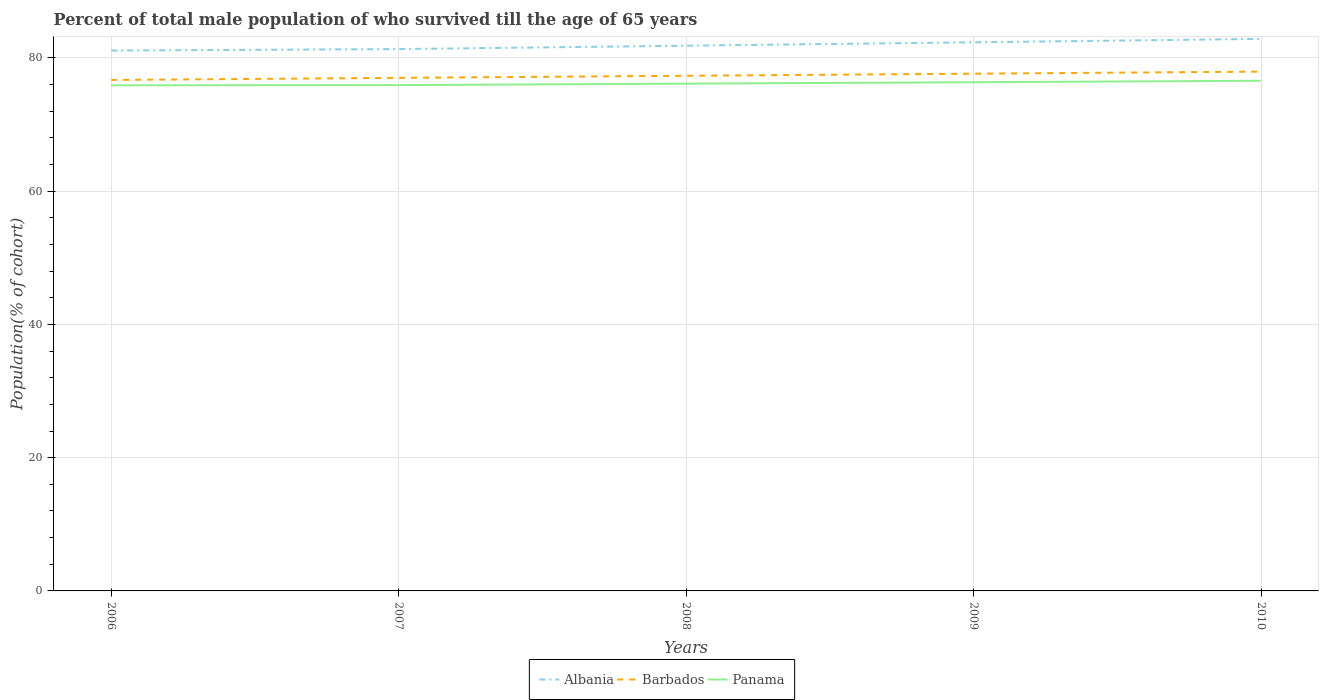Is the number of lines equal to the number of legend labels?
Your answer should be very brief. Yes. Across all years, what is the maximum percentage of total male population who survived till the age of 65 years in Barbados?
Offer a very short reply. 76.7. In which year was the percentage of total male population who survived till the age of 65 years in Panama maximum?
Give a very brief answer. 2006. What is the total percentage of total male population who survived till the age of 65 years in Panama in the graph?
Offer a very short reply. -0.25. What is the difference between the highest and the second highest percentage of total male population who survived till the age of 65 years in Panama?
Your answer should be very brief. 0.68. Is the percentage of total male population who survived till the age of 65 years in Albania strictly greater than the percentage of total male population who survived till the age of 65 years in Panama over the years?
Keep it short and to the point. No. How many lines are there?
Offer a terse response. 3. How many years are there in the graph?
Offer a terse response. 5. Does the graph contain grids?
Provide a succinct answer. Yes. How many legend labels are there?
Your response must be concise. 3. What is the title of the graph?
Provide a succinct answer. Percent of total male population of who survived till the age of 65 years. What is the label or title of the Y-axis?
Offer a very short reply. Population(% of cohort). What is the Population(% of cohort) in Albania in 2006?
Make the answer very short. 81.12. What is the Population(% of cohort) in Barbados in 2006?
Your answer should be very brief. 76.7. What is the Population(% of cohort) of Panama in 2006?
Your response must be concise. 75.9. What is the Population(% of cohort) in Albania in 2007?
Your answer should be very brief. 81.34. What is the Population(% of cohort) of Barbados in 2007?
Ensure brevity in your answer.  77.02. What is the Population(% of cohort) of Panama in 2007?
Ensure brevity in your answer.  75.93. What is the Population(% of cohort) of Albania in 2008?
Provide a short and direct response. 81.85. What is the Population(% of cohort) in Barbados in 2008?
Offer a very short reply. 77.33. What is the Population(% of cohort) in Panama in 2008?
Your response must be concise. 76.15. What is the Population(% of cohort) in Albania in 2009?
Make the answer very short. 82.36. What is the Population(% of cohort) in Barbados in 2009?
Your answer should be compact. 77.64. What is the Population(% of cohort) in Panama in 2009?
Provide a short and direct response. 76.37. What is the Population(% of cohort) of Albania in 2010?
Give a very brief answer. 82.87. What is the Population(% of cohort) of Barbados in 2010?
Ensure brevity in your answer.  77.96. What is the Population(% of cohort) in Panama in 2010?
Provide a short and direct response. 76.58. Across all years, what is the maximum Population(% of cohort) of Albania?
Your response must be concise. 82.87. Across all years, what is the maximum Population(% of cohort) in Barbados?
Provide a short and direct response. 77.96. Across all years, what is the maximum Population(% of cohort) of Panama?
Keep it short and to the point. 76.58. Across all years, what is the minimum Population(% of cohort) of Albania?
Provide a succinct answer. 81.12. Across all years, what is the minimum Population(% of cohort) of Barbados?
Provide a succinct answer. 76.7. Across all years, what is the minimum Population(% of cohort) in Panama?
Keep it short and to the point. 75.9. What is the total Population(% of cohort) in Albania in the graph?
Ensure brevity in your answer.  409.53. What is the total Population(% of cohort) in Barbados in the graph?
Your answer should be very brief. 386.65. What is the total Population(% of cohort) of Panama in the graph?
Ensure brevity in your answer.  380.93. What is the difference between the Population(% of cohort) of Albania in 2006 and that in 2007?
Provide a short and direct response. -0.22. What is the difference between the Population(% of cohort) in Barbados in 2006 and that in 2007?
Give a very brief answer. -0.32. What is the difference between the Population(% of cohort) of Panama in 2006 and that in 2007?
Your answer should be very brief. -0.03. What is the difference between the Population(% of cohort) of Albania in 2006 and that in 2008?
Give a very brief answer. -0.73. What is the difference between the Population(% of cohort) in Barbados in 2006 and that in 2008?
Keep it short and to the point. -0.63. What is the difference between the Population(% of cohort) of Panama in 2006 and that in 2008?
Your response must be concise. -0.25. What is the difference between the Population(% of cohort) of Albania in 2006 and that in 2009?
Your response must be concise. -1.24. What is the difference between the Population(% of cohort) in Barbados in 2006 and that in 2009?
Ensure brevity in your answer.  -0.94. What is the difference between the Population(% of cohort) of Panama in 2006 and that in 2009?
Make the answer very short. -0.46. What is the difference between the Population(% of cohort) in Albania in 2006 and that in 2010?
Ensure brevity in your answer.  -1.75. What is the difference between the Population(% of cohort) in Barbados in 2006 and that in 2010?
Offer a very short reply. -1.26. What is the difference between the Population(% of cohort) in Panama in 2006 and that in 2010?
Ensure brevity in your answer.  -0.68. What is the difference between the Population(% of cohort) of Albania in 2007 and that in 2008?
Give a very brief answer. -0.51. What is the difference between the Population(% of cohort) of Barbados in 2007 and that in 2008?
Your response must be concise. -0.31. What is the difference between the Population(% of cohort) of Panama in 2007 and that in 2008?
Ensure brevity in your answer.  -0.22. What is the difference between the Population(% of cohort) of Albania in 2007 and that in 2009?
Your answer should be very brief. -1.02. What is the difference between the Population(% of cohort) of Barbados in 2007 and that in 2009?
Your answer should be compact. -0.62. What is the difference between the Population(% of cohort) in Panama in 2007 and that in 2009?
Your response must be concise. -0.43. What is the difference between the Population(% of cohort) of Albania in 2007 and that in 2010?
Your answer should be very brief. -1.53. What is the difference between the Population(% of cohort) of Barbados in 2007 and that in 2010?
Give a very brief answer. -0.94. What is the difference between the Population(% of cohort) of Panama in 2007 and that in 2010?
Your answer should be compact. -0.65. What is the difference between the Population(% of cohort) of Albania in 2008 and that in 2009?
Offer a very short reply. -0.51. What is the difference between the Population(% of cohort) of Barbados in 2008 and that in 2009?
Give a very brief answer. -0.31. What is the difference between the Population(% of cohort) of Panama in 2008 and that in 2009?
Your response must be concise. -0.22. What is the difference between the Population(% of cohort) of Albania in 2008 and that in 2010?
Keep it short and to the point. -1.02. What is the difference between the Population(% of cohort) in Barbados in 2008 and that in 2010?
Provide a short and direct response. -0.62. What is the difference between the Population(% of cohort) of Panama in 2008 and that in 2010?
Your response must be concise. -0.43. What is the difference between the Population(% of cohort) of Albania in 2009 and that in 2010?
Make the answer very short. -0.51. What is the difference between the Population(% of cohort) of Barbados in 2009 and that in 2010?
Provide a short and direct response. -0.31. What is the difference between the Population(% of cohort) of Panama in 2009 and that in 2010?
Make the answer very short. -0.22. What is the difference between the Population(% of cohort) in Albania in 2006 and the Population(% of cohort) in Barbados in 2007?
Offer a terse response. 4.1. What is the difference between the Population(% of cohort) in Albania in 2006 and the Population(% of cohort) in Panama in 2007?
Your response must be concise. 5.18. What is the difference between the Population(% of cohort) in Barbados in 2006 and the Population(% of cohort) in Panama in 2007?
Offer a very short reply. 0.77. What is the difference between the Population(% of cohort) of Albania in 2006 and the Population(% of cohort) of Barbados in 2008?
Your answer should be very brief. 3.79. What is the difference between the Population(% of cohort) of Albania in 2006 and the Population(% of cohort) of Panama in 2008?
Ensure brevity in your answer.  4.97. What is the difference between the Population(% of cohort) in Barbados in 2006 and the Population(% of cohort) in Panama in 2008?
Your answer should be very brief. 0.55. What is the difference between the Population(% of cohort) of Albania in 2006 and the Population(% of cohort) of Barbados in 2009?
Make the answer very short. 3.47. What is the difference between the Population(% of cohort) of Albania in 2006 and the Population(% of cohort) of Panama in 2009?
Provide a succinct answer. 4.75. What is the difference between the Population(% of cohort) in Barbados in 2006 and the Population(% of cohort) in Panama in 2009?
Keep it short and to the point. 0.34. What is the difference between the Population(% of cohort) in Albania in 2006 and the Population(% of cohort) in Barbados in 2010?
Provide a short and direct response. 3.16. What is the difference between the Population(% of cohort) in Albania in 2006 and the Population(% of cohort) in Panama in 2010?
Offer a very short reply. 4.54. What is the difference between the Population(% of cohort) of Barbados in 2006 and the Population(% of cohort) of Panama in 2010?
Offer a terse response. 0.12. What is the difference between the Population(% of cohort) of Albania in 2007 and the Population(% of cohort) of Barbados in 2008?
Offer a very short reply. 4. What is the difference between the Population(% of cohort) in Albania in 2007 and the Population(% of cohort) in Panama in 2008?
Offer a terse response. 5.19. What is the difference between the Population(% of cohort) in Barbados in 2007 and the Population(% of cohort) in Panama in 2008?
Your response must be concise. 0.87. What is the difference between the Population(% of cohort) in Albania in 2007 and the Population(% of cohort) in Barbados in 2009?
Your answer should be very brief. 3.69. What is the difference between the Population(% of cohort) of Albania in 2007 and the Population(% of cohort) of Panama in 2009?
Keep it short and to the point. 4.97. What is the difference between the Population(% of cohort) of Barbados in 2007 and the Population(% of cohort) of Panama in 2009?
Your answer should be compact. 0.65. What is the difference between the Population(% of cohort) of Albania in 2007 and the Population(% of cohort) of Barbados in 2010?
Provide a short and direct response. 3.38. What is the difference between the Population(% of cohort) in Albania in 2007 and the Population(% of cohort) in Panama in 2010?
Ensure brevity in your answer.  4.76. What is the difference between the Population(% of cohort) of Barbados in 2007 and the Population(% of cohort) of Panama in 2010?
Your answer should be compact. 0.44. What is the difference between the Population(% of cohort) of Albania in 2008 and the Population(% of cohort) of Barbados in 2009?
Ensure brevity in your answer.  4.2. What is the difference between the Population(% of cohort) of Albania in 2008 and the Population(% of cohort) of Panama in 2009?
Offer a terse response. 5.48. What is the difference between the Population(% of cohort) in Barbados in 2008 and the Population(% of cohort) in Panama in 2009?
Give a very brief answer. 0.97. What is the difference between the Population(% of cohort) of Albania in 2008 and the Population(% of cohort) of Barbados in 2010?
Your answer should be very brief. 3.89. What is the difference between the Population(% of cohort) in Albania in 2008 and the Population(% of cohort) in Panama in 2010?
Your response must be concise. 5.27. What is the difference between the Population(% of cohort) of Barbados in 2008 and the Population(% of cohort) of Panama in 2010?
Offer a very short reply. 0.75. What is the difference between the Population(% of cohort) of Albania in 2009 and the Population(% of cohort) of Barbados in 2010?
Make the answer very short. 4.4. What is the difference between the Population(% of cohort) in Albania in 2009 and the Population(% of cohort) in Panama in 2010?
Ensure brevity in your answer.  5.78. What is the difference between the Population(% of cohort) of Barbados in 2009 and the Population(% of cohort) of Panama in 2010?
Give a very brief answer. 1.06. What is the average Population(% of cohort) in Albania per year?
Provide a short and direct response. 81.91. What is the average Population(% of cohort) of Barbados per year?
Offer a terse response. 77.33. What is the average Population(% of cohort) of Panama per year?
Make the answer very short. 76.19. In the year 2006, what is the difference between the Population(% of cohort) in Albania and Population(% of cohort) in Barbados?
Your answer should be compact. 4.42. In the year 2006, what is the difference between the Population(% of cohort) of Albania and Population(% of cohort) of Panama?
Ensure brevity in your answer.  5.21. In the year 2006, what is the difference between the Population(% of cohort) in Barbados and Population(% of cohort) in Panama?
Offer a terse response. 0.8. In the year 2007, what is the difference between the Population(% of cohort) of Albania and Population(% of cohort) of Barbados?
Offer a very short reply. 4.32. In the year 2007, what is the difference between the Population(% of cohort) in Albania and Population(% of cohort) in Panama?
Keep it short and to the point. 5.4. In the year 2007, what is the difference between the Population(% of cohort) in Barbados and Population(% of cohort) in Panama?
Provide a short and direct response. 1.09. In the year 2008, what is the difference between the Population(% of cohort) in Albania and Population(% of cohort) in Barbados?
Your response must be concise. 4.51. In the year 2008, what is the difference between the Population(% of cohort) in Albania and Population(% of cohort) in Panama?
Provide a short and direct response. 5.7. In the year 2008, what is the difference between the Population(% of cohort) of Barbados and Population(% of cohort) of Panama?
Your answer should be compact. 1.18. In the year 2009, what is the difference between the Population(% of cohort) in Albania and Population(% of cohort) in Barbados?
Your response must be concise. 4.71. In the year 2009, what is the difference between the Population(% of cohort) of Albania and Population(% of cohort) of Panama?
Offer a very short reply. 5.99. In the year 2009, what is the difference between the Population(% of cohort) in Barbados and Population(% of cohort) in Panama?
Offer a terse response. 1.28. In the year 2010, what is the difference between the Population(% of cohort) of Albania and Population(% of cohort) of Barbados?
Your response must be concise. 4.91. In the year 2010, what is the difference between the Population(% of cohort) of Albania and Population(% of cohort) of Panama?
Offer a very short reply. 6.29. In the year 2010, what is the difference between the Population(% of cohort) in Barbados and Population(% of cohort) in Panama?
Your answer should be compact. 1.38. What is the ratio of the Population(% of cohort) of Albania in 2006 to that in 2007?
Your answer should be very brief. 1. What is the ratio of the Population(% of cohort) of Albania in 2006 to that in 2008?
Provide a short and direct response. 0.99. What is the ratio of the Population(% of cohort) in Barbados in 2006 to that in 2008?
Make the answer very short. 0.99. What is the ratio of the Population(% of cohort) in Albania in 2006 to that in 2009?
Keep it short and to the point. 0.98. What is the ratio of the Population(% of cohort) of Barbados in 2006 to that in 2009?
Keep it short and to the point. 0.99. What is the ratio of the Population(% of cohort) of Albania in 2006 to that in 2010?
Give a very brief answer. 0.98. What is the ratio of the Population(% of cohort) of Barbados in 2006 to that in 2010?
Offer a very short reply. 0.98. What is the ratio of the Population(% of cohort) of Albania in 2007 to that in 2009?
Make the answer very short. 0.99. What is the ratio of the Population(% of cohort) of Barbados in 2007 to that in 2009?
Ensure brevity in your answer.  0.99. What is the ratio of the Population(% of cohort) in Panama in 2007 to that in 2009?
Provide a short and direct response. 0.99. What is the ratio of the Population(% of cohort) of Albania in 2007 to that in 2010?
Your answer should be very brief. 0.98. What is the ratio of the Population(% of cohort) in Barbados in 2008 to that in 2009?
Offer a very short reply. 1. What is the ratio of the Population(% of cohort) of Barbados in 2008 to that in 2010?
Provide a short and direct response. 0.99. What is the ratio of the Population(% of cohort) of Panama in 2008 to that in 2010?
Your response must be concise. 0.99. What is the ratio of the Population(% of cohort) of Barbados in 2009 to that in 2010?
Offer a terse response. 1. What is the ratio of the Population(% of cohort) of Panama in 2009 to that in 2010?
Your answer should be compact. 1. What is the difference between the highest and the second highest Population(% of cohort) of Albania?
Provide a succinct answer. 0.51. What is the difference between the highest and the second highest Population(% of cohort) in Barbados?
Ensure brevity in your answer.  0.31. What is the difference between the highest and the second highest Population(% of cohort) in Panama?
Make the answer very short. 0.22. What is the difference between the highest and the lowest Population(% of cohort) of Albania?
Provide a succinct answer. 1.75. What is the difference between the highest and the lowest Population(% of cohort) in Barbados?
Provide a succinct answer. 1.26. What is the difference between the highest and the lowest Population(% of cohort) in Panama?
Offer a terse response. 0.68. 